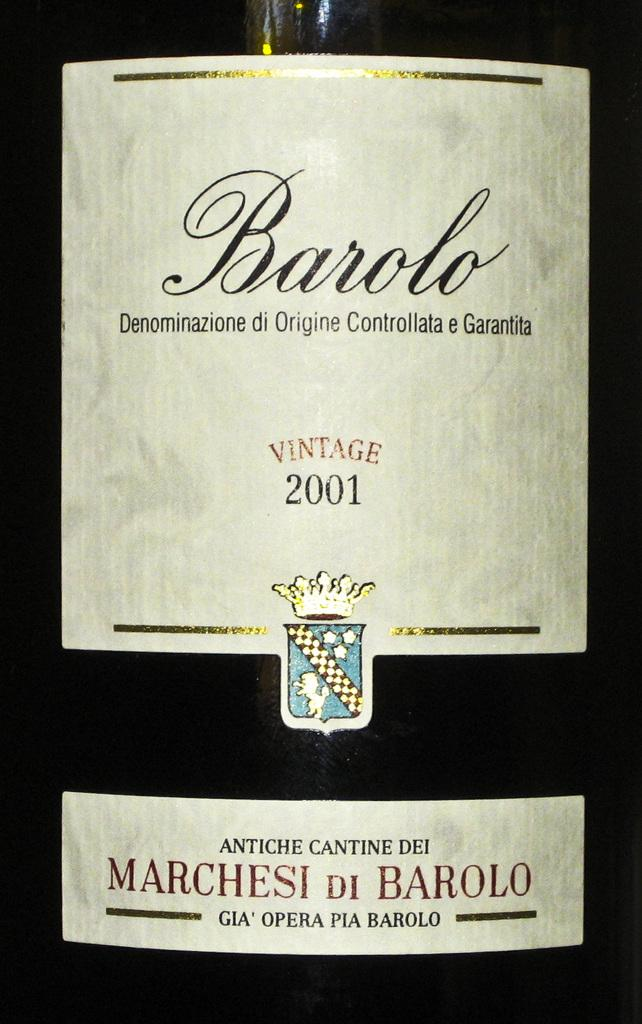<image>
Share a concise interpretation of the image provided. The white label of a bottle of Barolo 2001 vintage wine. 